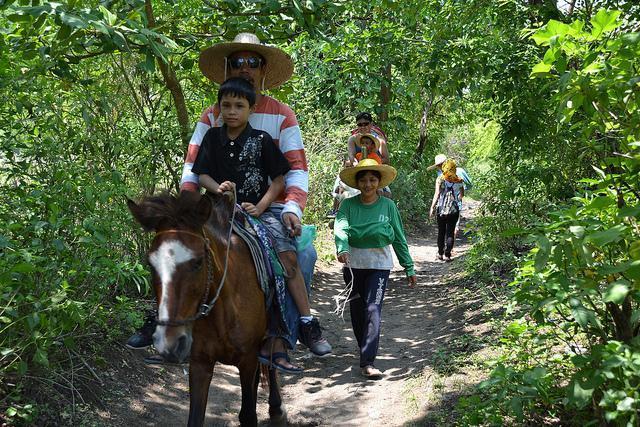How many people are riding an animal?
Give a very brief answer. 2. How many people can you see?
Give a very brief answer. 4. 